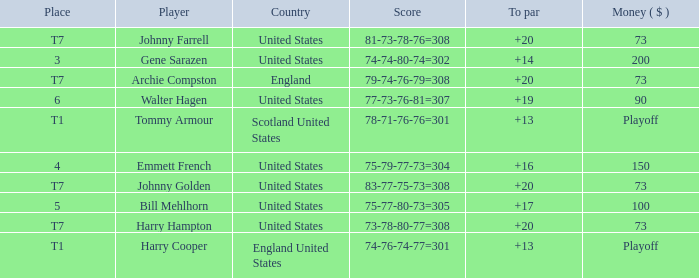What is the score for the United States when Harry Hampton is the player and the money is $73? 73-78-80-77=308. Can you parse all the data within this table? {'header': ['Place', 'Player', 'Country', 'Score', 'To par', 'Money ( $ )'], 'rows': [['T7', 'Johnny Farrell', 'United States', '81-73-78-76=308', '+20', '73'], ['3', 'Gene Sarazen', 'United States', '74-74-80-74=302', '+14', '200'], ['T7', 'Archie Compston', 'England', '79-74-76-79=308', '+20', '73'], ['6', 'Walter Hagen', 'United States', '77-73-76-81=307', '+19', '90'], ['T1', 'Tommy Armour', 'Scotland United States', '78-71-76-76=301', '+13', 'Playoff'], ['4', 'Emmett French', 'United States', '75-79-77-73=304', '+16', '150'], ['T7', 'Johnny Golden', 'United States', '83-77-75-73=308', '+20', '73'], ['5', 'Bill Mehlhorn', 'United States', '75-77-80-73=305', '+17', '100'], ['T7', 'Harry Hampton', 'United States', '73-78-80-77=308', '+20', '73'], ['T1', 'Harry Cooper', 'England United States', '74-76-74-77=301', '+13', 'Playoff']]} 